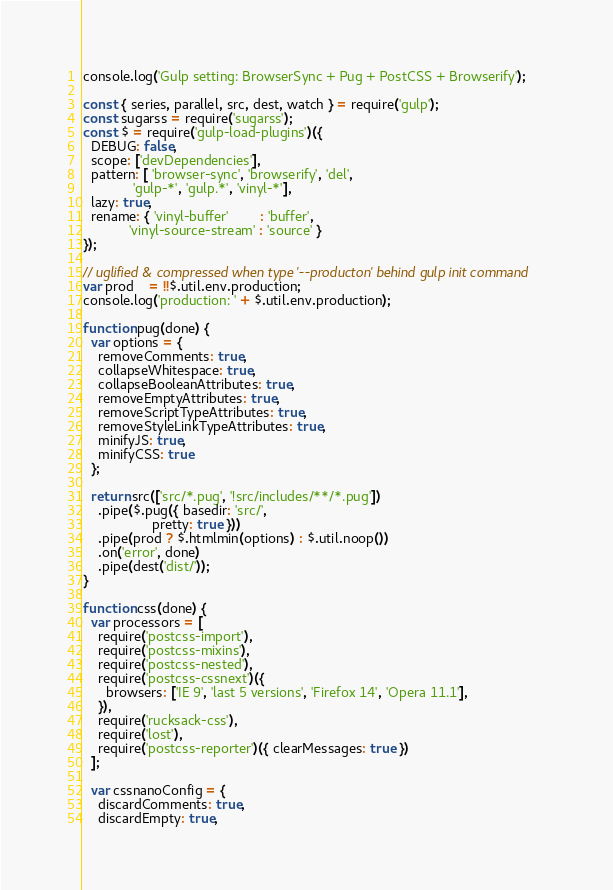<code> <loc_0><loc_0><loc_500><loc_500><_JavaScript_>console.log('Gulp setting: BrowserSync + Pug + PostCSS + Browserify');

const { series, parallel, src, dest, watch } = require('gulp');
const sugarss = require('sugarss');
const $ = require('gulp-load-plugins')({
  DEBUG: false,
  scope: ['devDependencies'],
  pattern: [ 'browser-sync', 'browserify', 'del',
             'gulp-*', 'gulp.*', 'vinyl-*'],
  lazy: true,
  rename: { 'vinyl-buffer'        : 'buffer',
            'vinyl-source-stream' : 'source' }
});

// uglified & compressed when type '--producton' behind gulp init command
var prod    = !!$.util.env.production;
console.log('production: ' + $.util.env.production);

function pug(done) {
  var options = {
    removeComments: true,
    collapseWhitespace: true,
    collapseBooleanAttributes: true,
    removeEmptyAttributes: true,
    removeScriptTypeAttributes: true,
    removeStyleLinkTypeAttributes: true,
    minifyJS: true,
    minifyCSS: true
  };
  
  return src(['src/*.pug', '!src/includes/**/*.pug'])
    .pipe($.pug({ basedir: 'src/',
                  pretty: true }))
    .pipe(prod ? $.htmlmin(options) : $.util.noop())
    .on('error', done)
    .pipe(dest('dist/'));
}

function css(done) {
  var processors = [
    require('postcss-import'),
    require('postcss-mixins'),
    require('postcss-nested'),
    require('postcss-cssnext')({
      browsers: ['IE 9', 'last 5 versions', 'Firefox 14', 'Opera 11.1'],
    }),
    require('rucksack-css'),
    require('lost'),
    require('postcss-reporter')({ clearMessages: true })
  ];

  var cssnanoConfig = {
    discardComments: true,
    discardEmpty: true,</code> 